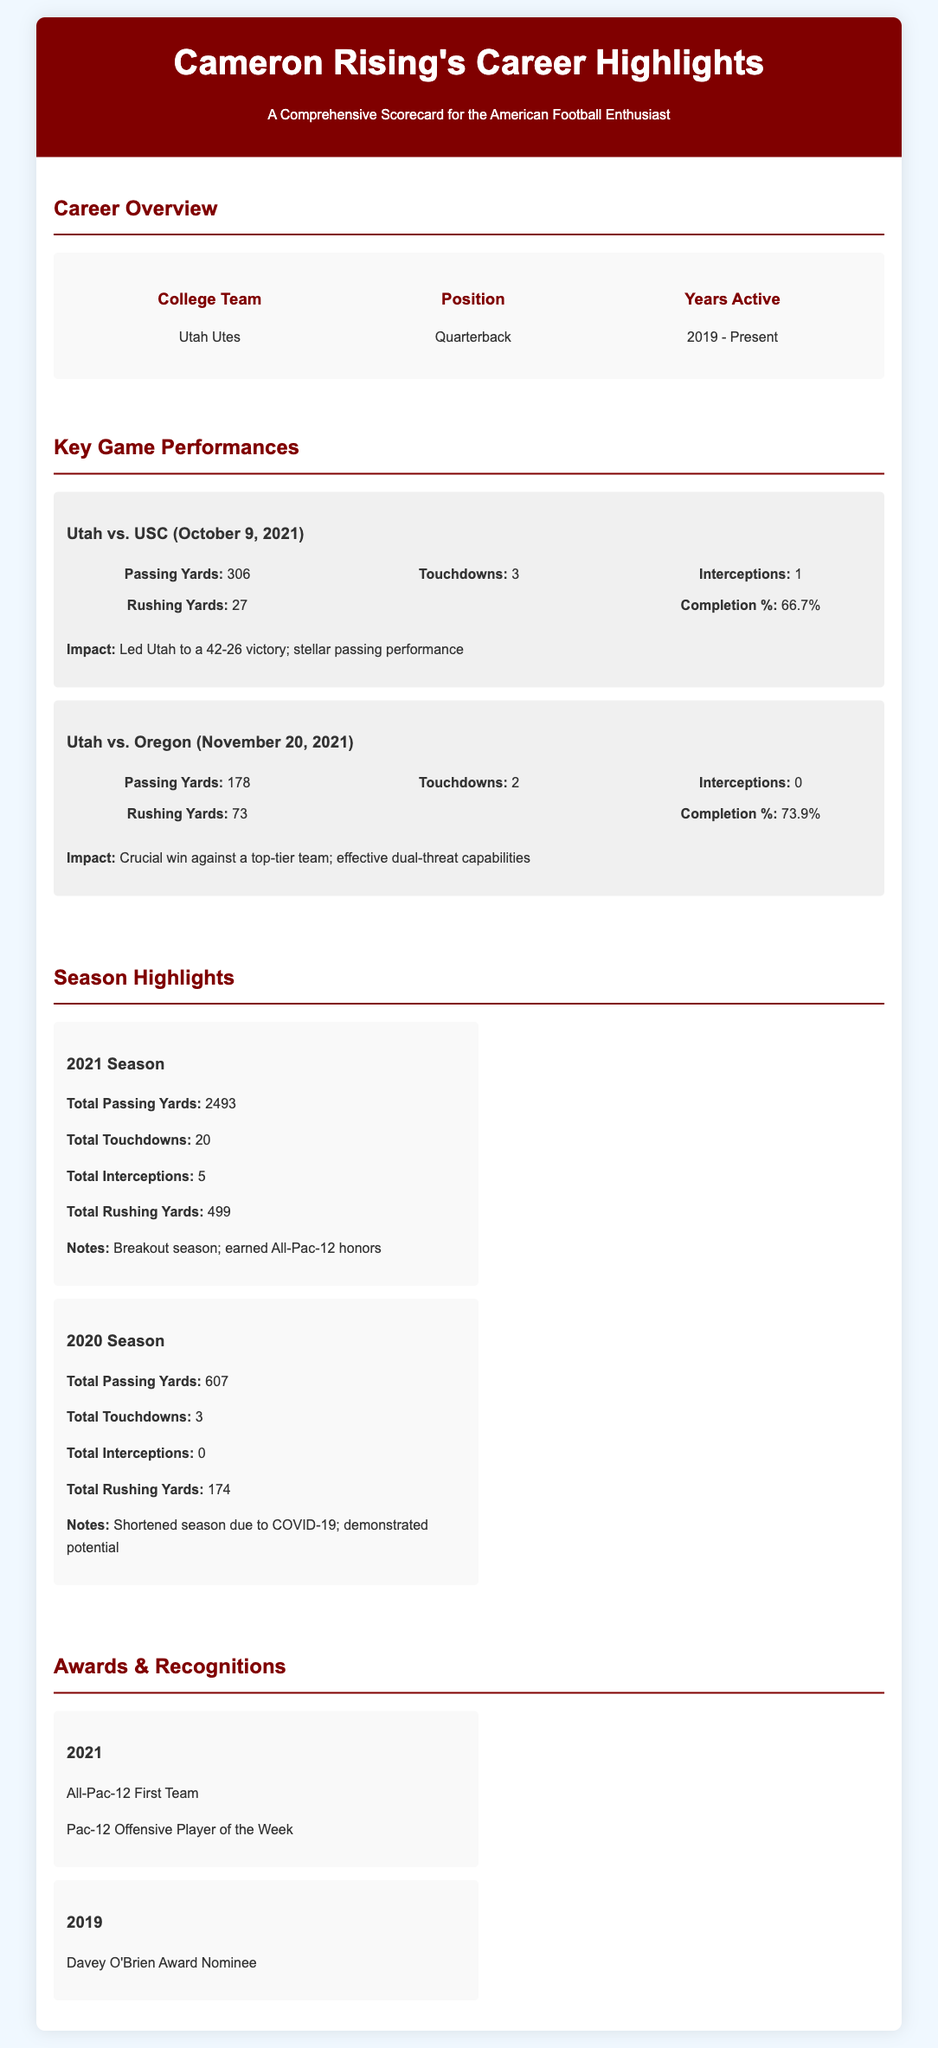What college team did Cameron Rising play for? The document clearly states that Cameron Rising played for the Utah Utes.
Answer: Utah Utes What position does Cameron Rising play? The document lists the position of Cameron Rising as a quarterback.
Answer: Quarterback How many years has Cameron Rising been active? Based on the timeline in the document, Cameron Rising has been active from 2019 to the present, which counts as 5 years.
Answer: 5 years What were Cameron Rising's passing yards against USC on October 9, 2021? The game performance section specifically states that his passing yards in that game were 306.
Answer: 306 How many total touchdowns did Cameron Rising throw in the 2021 season? The season highlights indicate that he threw a total of 20 touchdowns during the 2021 season.
Answer: 20 In which year did Cameron Rising earn All-Pac-12 honors? According to the document, All-Pac-12 honors were earned in the 2021 season.
Answer: 2021 What was Cameron Rising's rushing yard total in the 2020 season? The document explicitly notes that his total rushing yards for the 2020 season were 174.
Answer: 174 How many touchdowns did he have in the game against Oregon on November 20, 2021? The game stats indicate that he scored 2 touchdowns during the game against Oregon.
Answer: 2 What recognition did Cameron Rising receive in 2019? The document shows that he was a nominee for the Davey O'Brien Award in 2019.
Answer: Davey O'Brien Award Nominee 